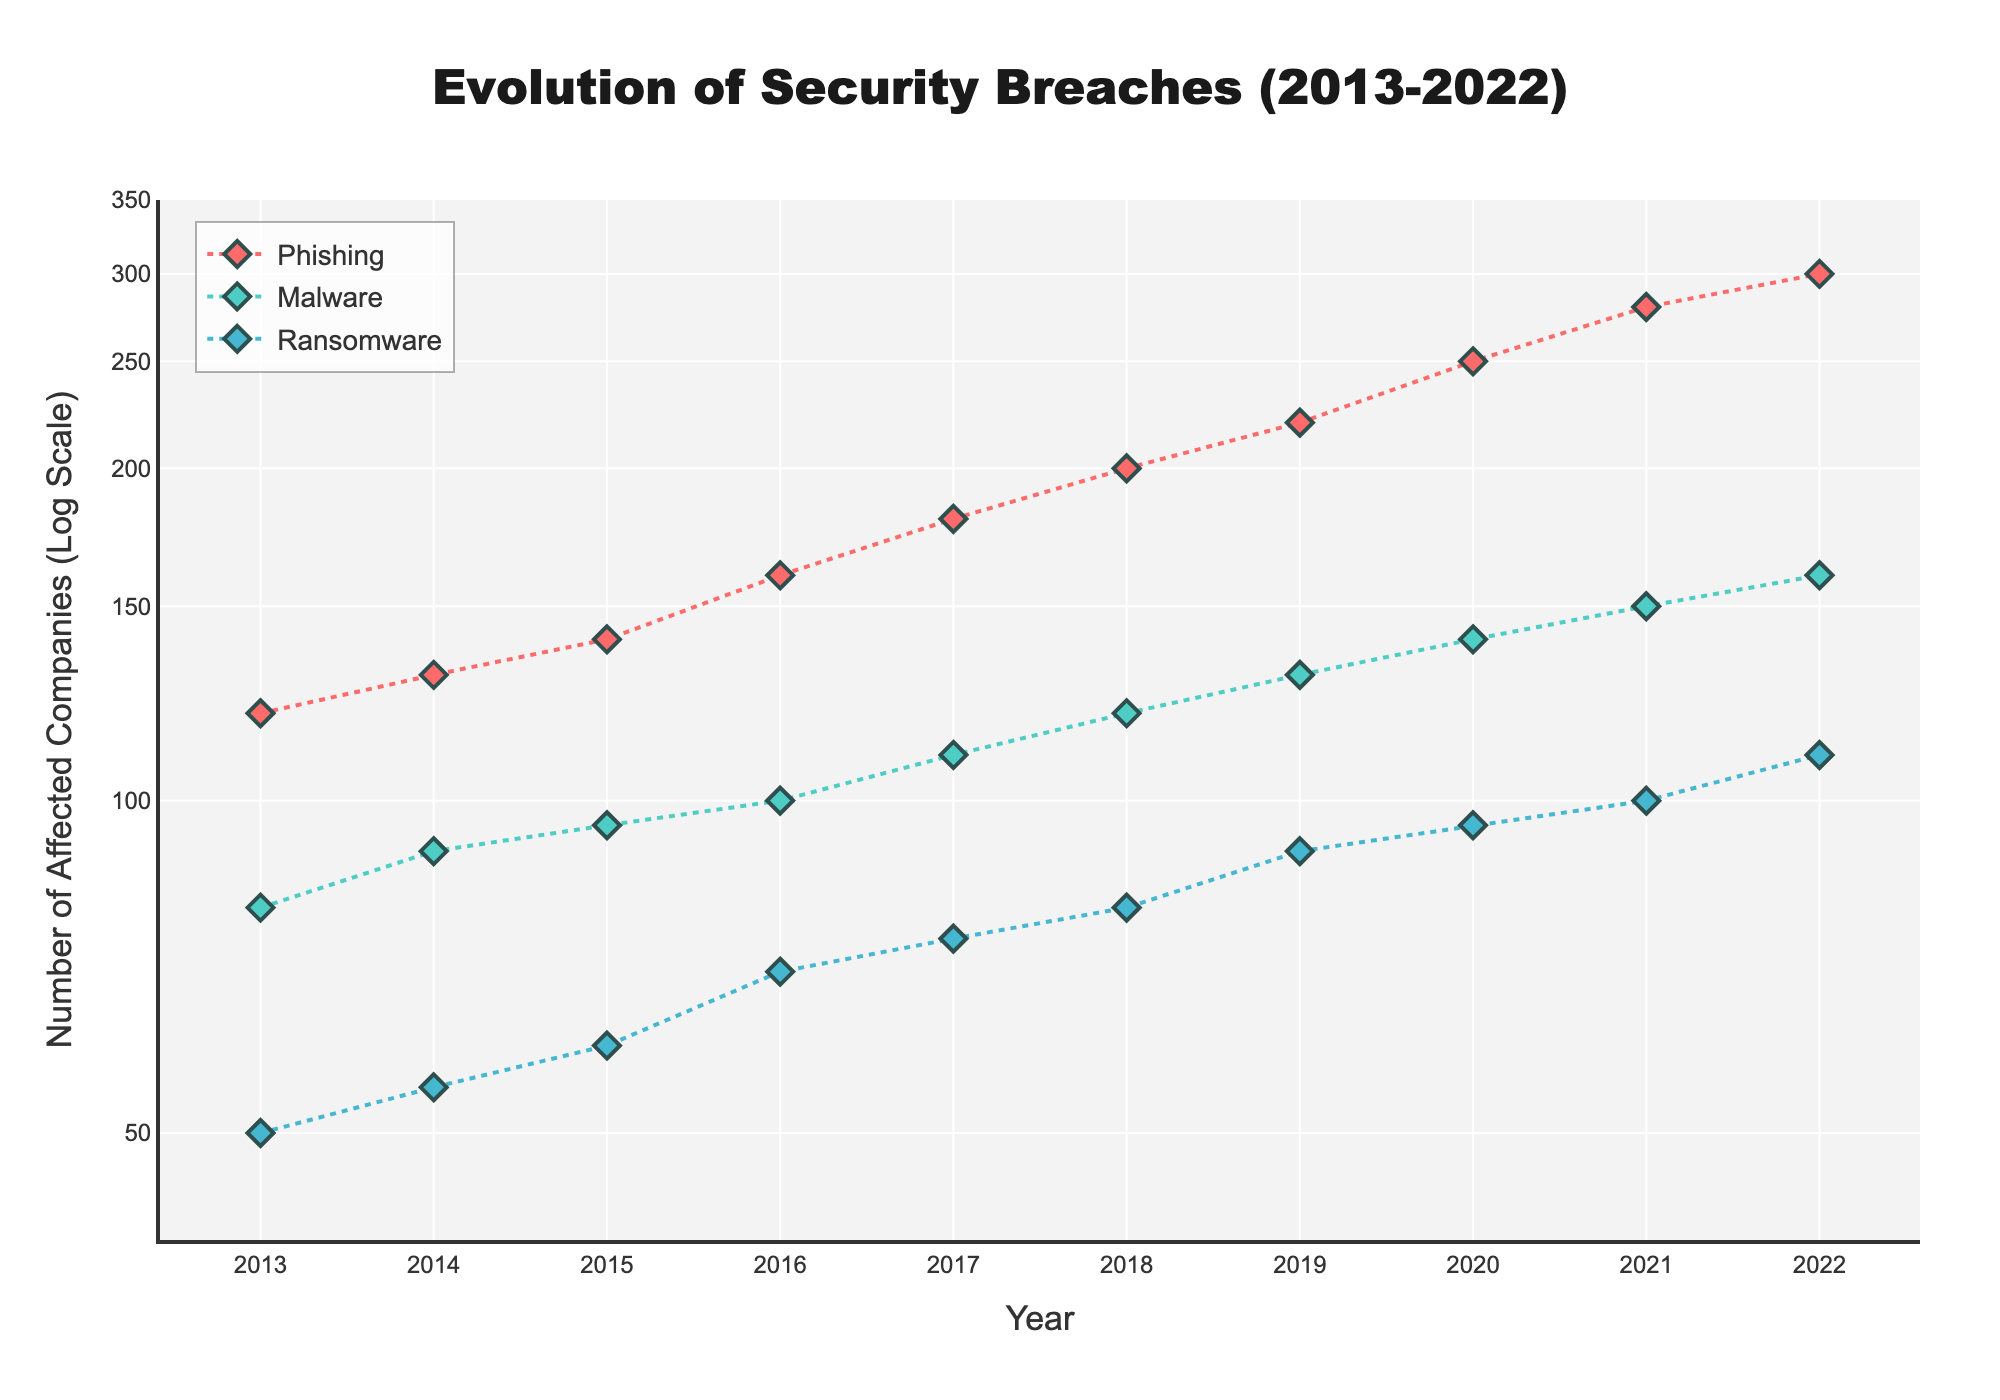What's the title of the figure? The title of the figure is prominently shown at the top and it states "Evolution of Security Breaches (2013-2022)"
Answer: Evolution of Security Breaches (2013-2022) What does the y-axis represent? The y-axis is labeled "Number of Affected Companies (Log Scale)", indicating it represents the number of companies affected by security breaches, and it uses a logarithmic scale.
Answer: Number of Affected Companies (Log Scale) Which type of security breach has affected the most companies in 2022? According to the figure's data points and lines, Phishing affected the most companies in 2022, as its point is the highest on the y-axis for that year.
Answer: Phishing How has the number of companies affected by Malware changed from 2013 to 2022? To answer this, compare the y-values (number of affected companies) for Malware in 2013 and 2022. Malware affected 80 companies in 2013 and 160 in 2022, indicating a doubling in the number of affected companies over the period.
Answer: Doubled Which year saw the greatest increase in the number of companies affected by Ransomware compared to the previous year? By examining the lines and points for Ransomware year-to-year, the largest increase is from 2018 to 2019, where the number of affected companies went from 80 to 90.
Answer: 2019 Which type of security breach experienced the most consistent increase in the number of affected companies over the decade? The most consistently increasing line is for Phishing, which rises steadily each year from 2013 to 2022.
Answer: Phishing Compare the number of companies affected by Malware in 2013 and Phishing in 2013. Which one is higher and by how much? In 2013, Malware affected 80 companies and Phishing affected 120 companies. The difference is 120 - 80 = 40 companies.
Answer: Phishing is higher by 40 companies What is the trend in the number of companies affected by Ransomware from 2014 to 2017? The scatter plot shows an upward trend for Ransomware with increasing points and connecting lines from 2014 to 2017, indicating a steady increase each year.
Answer: Steadily increasing Estimate the rate of increase in the number of companies affected by Phishing from 2017 to 2019. In 2017, 180 companies were affected by Phishing, and this number increased to 220 by 2019. The increase is 220 - 180 = 40 companies over 2 years, estimating an average increase of 40/2 = 20 companies per year.
Answer: 20 companies per year 